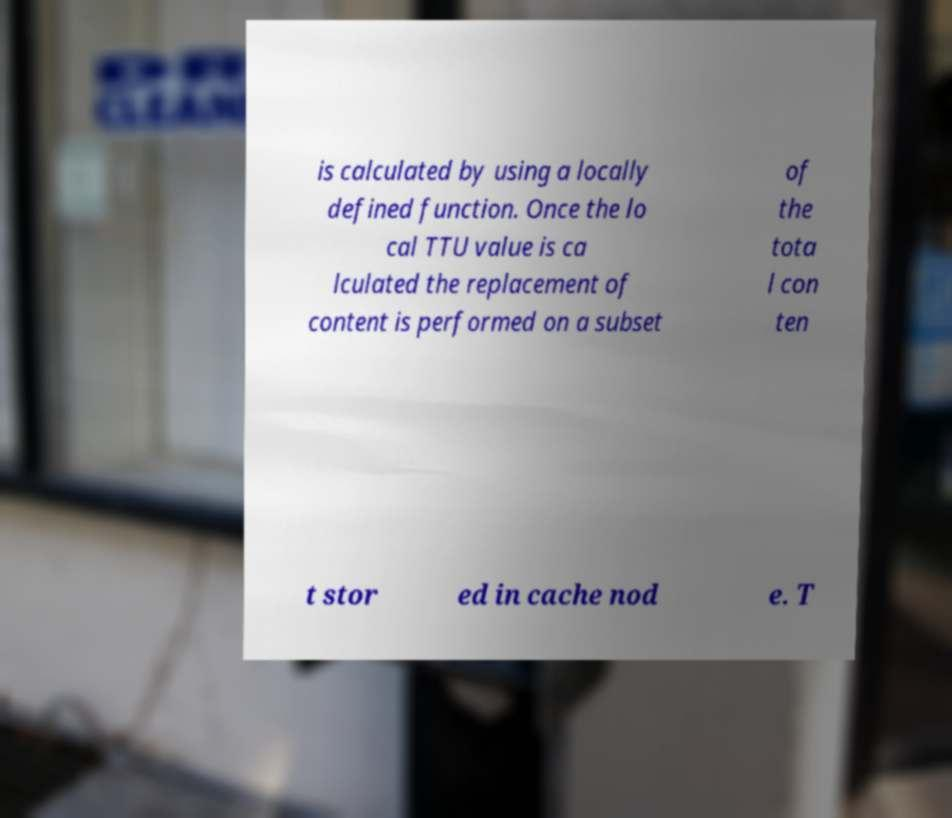Could you assist in decoding the text presented in this image and type it out clearly? is calculated by using a locally defined function. Once the lo cal TTU value is ca lculated the replacement of content is performed on a subset of the tota l con ten t stor ed in cache nod e. T 